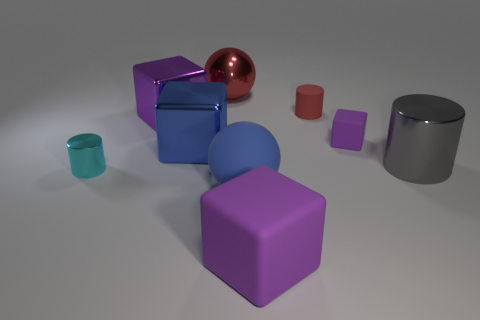What is the size of the purple rubber object that is in front of the small purple object?
Keep it short and to the point. Large. There is a big cube that is in front of the large gray thing; what material is it?
Provide a short and direct response. Rubber. How many blue things are either large matte spheres or blocks?
Your answer should be very brief. 2. Is the tiny purple thing made of the same material as the sphere that is in front of the large gray metal object?
Provide a short and direct response. Yes. Is the number of purple rubber blocks that are in front of the blue rubber ball the same as the number of shiny cylinders that are behind the tiny cyan shiny cylinder?
Give a very brief answer. Yes. There is a red matte cylinder; is its size the same as the purple rubber thing behind the tiny cyan metallic cylinder?
Your response must be concise. Yes. Is the number of rubber cylinders that are behind the purple metal cube greater than the number of large cyan shiny objects?
Offer a terse response. Yes. What number of metallic balls have the same size as the blue metal cube?
Give a very brief answer. 1. There is a purple thing that is in front of the small metal cylinder; does it have the same size as the metallic object in front of the large cylinder?
Make the answer very short. No. Is the number of rubber cubes that are in front of the cyan cylinder greater than the number of large purple metal things on the right side of the red shiny object?
Offer a very short reply. Yes. 